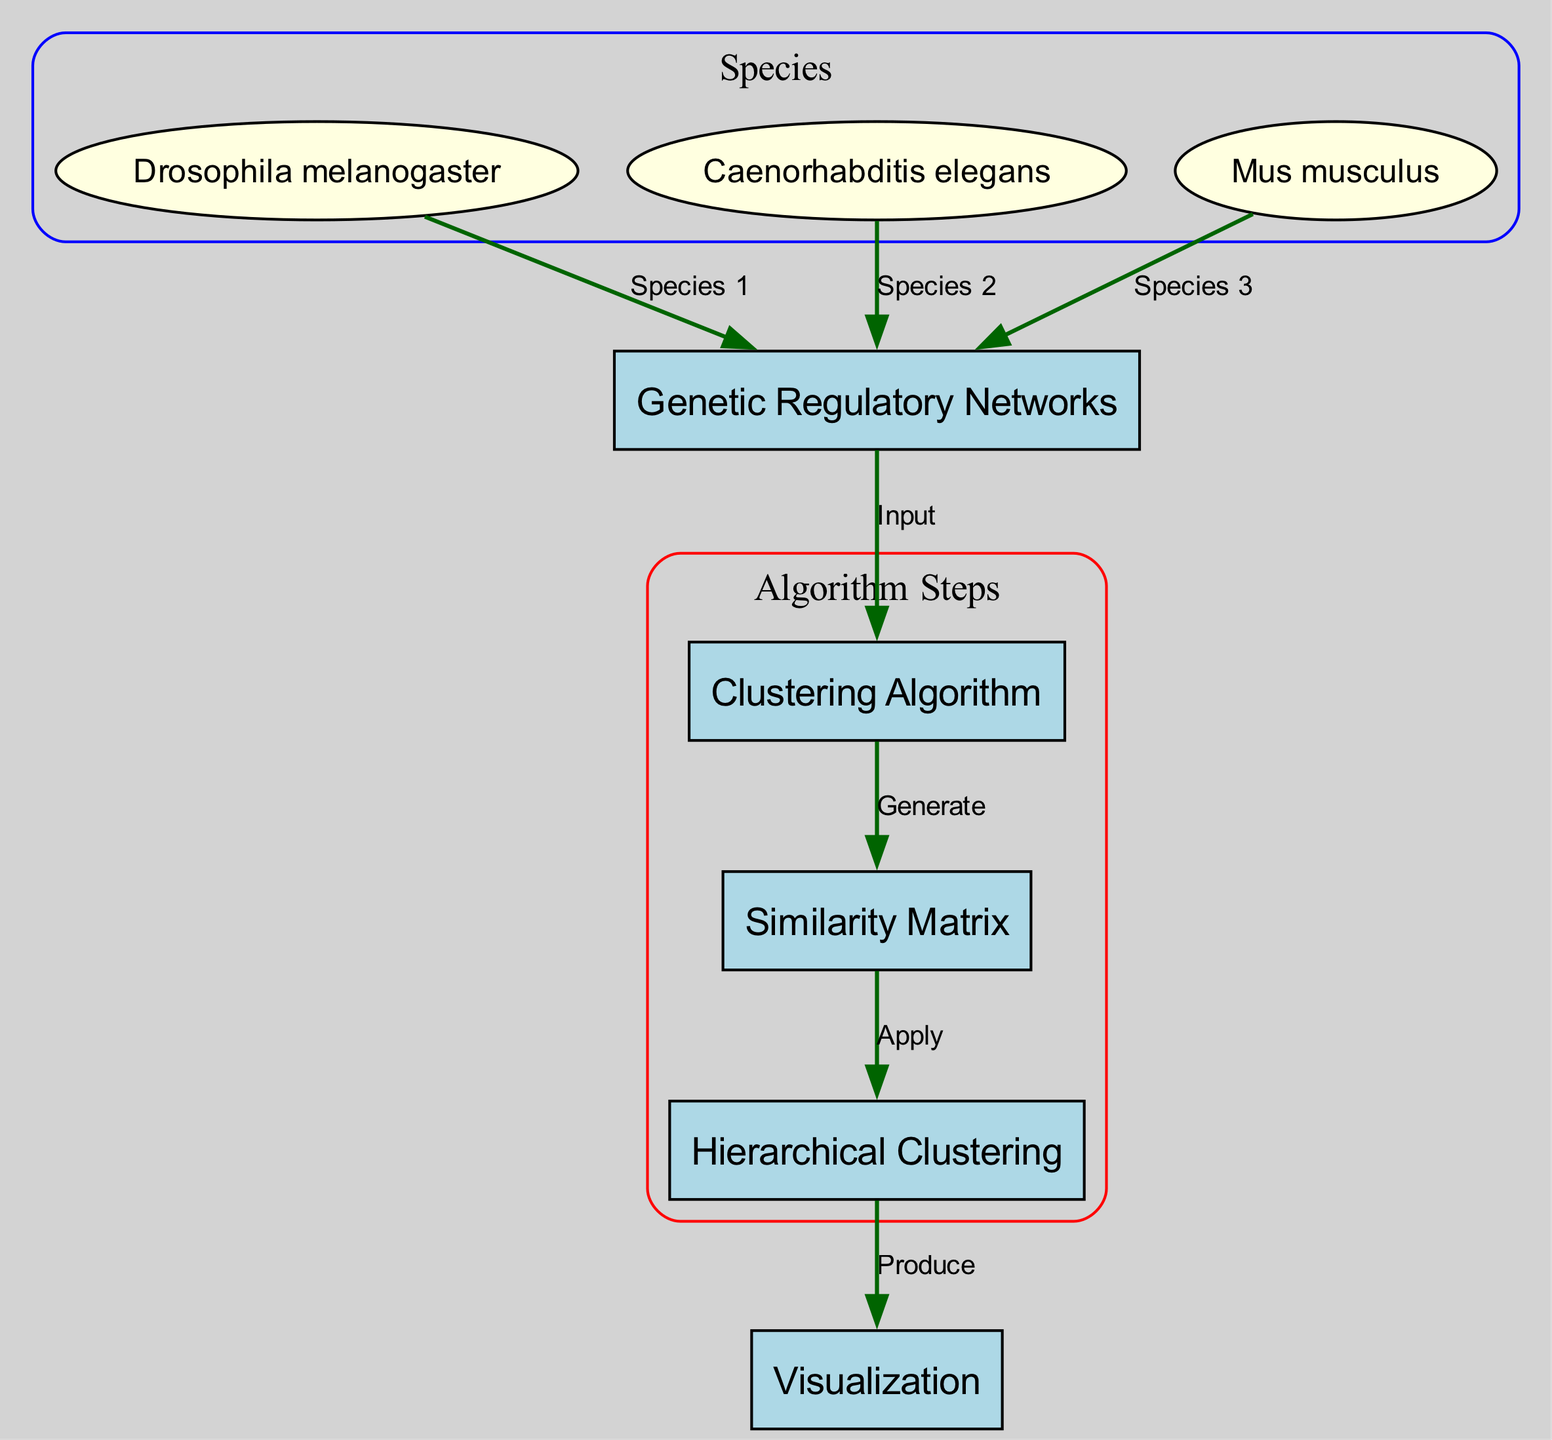What is the main focus of this diagram? The diagram primarily focuses on the clustering of genetic regulatory networks across various species, highlighting the steps involved in processing and analyzing these networks.
Answer: Genetic Regulatory Networks How many species are represented in the diagram? There are three species represented in the diagram, namely Drosophila melanogaster, Caenorhabditis elegans, and Mus musculus.
Answer: 3 Which species is linked to the Genetic Regulatory Networks? Drosophila melanogaster, Caenorhabditis elegans, and Mus musculus are all linked to the Genetic Regulatory Networks as they are displayed in the diagram as inputs representing distinct species.
Answer: Drosophila melanogaster, Caenorhabditis elegans, Mus musculus What is generated by the Clustering Algorithm? The clustering algorithm generates a similarity matrix which is essential for comparing the genetic regulatory networks among the species.
Answer: Similarity Matrix What is the final output produced in the diagram? The final output is a visualization that effectively represents the results of the hierarchical clustering applied to the similarity matrix.
Answer: Visualization What process follows after generating the Similarity Matrix? After generating the similarity matrix, the next step is to apply hierarchical clustering to analyze the similarities among the networks.
Answer: Apply Which algorithm is used to analyze the networks? The algorithm used to analyze the networks, as indicated in the diagram, is Hierarchical Clustering.
Answer: Hierarchical Clustering What is the relationship between the Clustering Algorithm and the Similarity Matrix? The Clustering Algorithm generates the Similarity Matrix, establishing a direct input-output relationship between these two components in the diagram.
Answer: Generate How many edges connect nodes in the diagram? The diagram consists of seven edges that describe the connections between the nodes and their relationships.
Answer: 7 